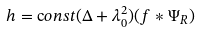Convert formula to latex. <formula><loc_0><loc_0><loc_500><loc_500>h = { \mathrm c o n s t } ( \Delta + \lambda _ { 0 } ^ { 2 } ) ( f * \Psi _ { R } )</formula> 